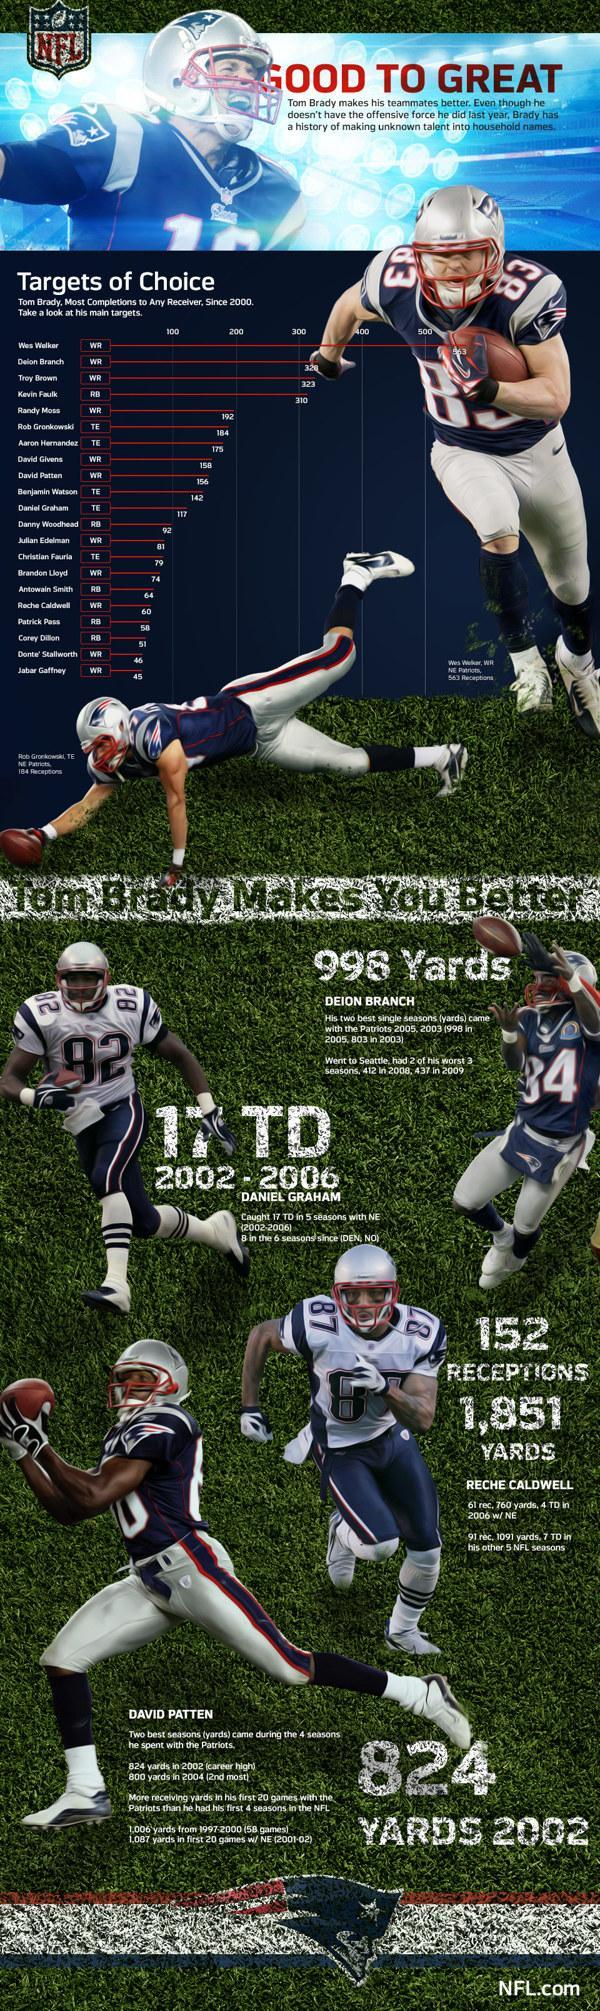What is the jersey number of the player Daniel Graham?
Answer the question with a short phrase. 82 What is the name of the player to the right side of Daniel Graham ? Deion Branch Which team do the players in the document belong to, New England Patriots, Tampa Bay Buccaneers, or Minnesota Vikings? New England Patriots What is the difference is most completions between Wes Walker and the person below him on the board? 235 